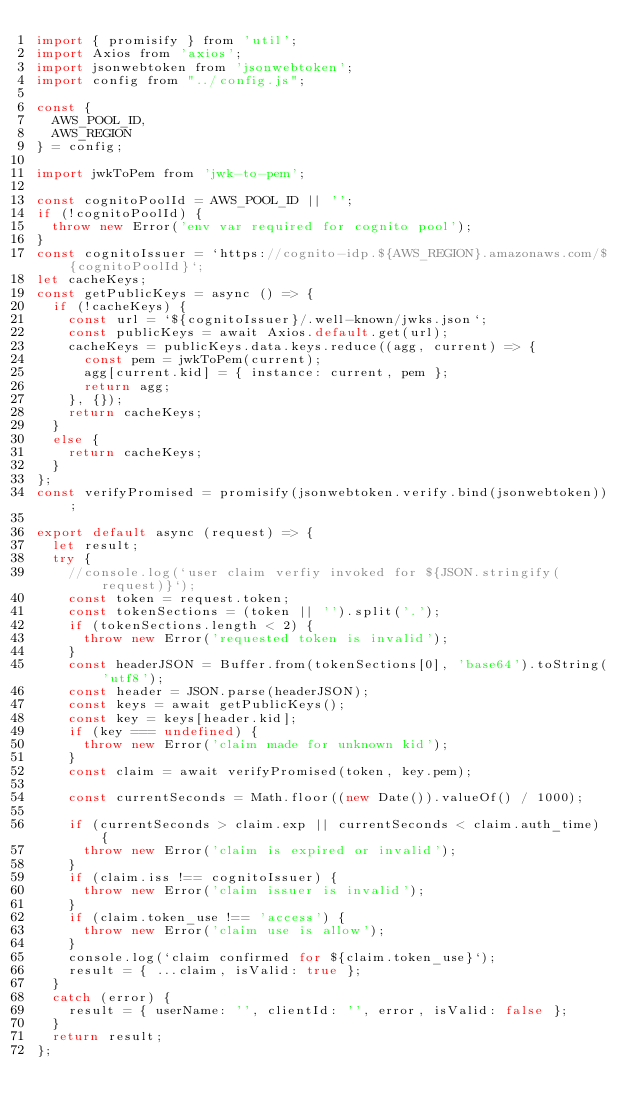Convert code to text. <code><loc_0><loc_0><loc_500><loc_500><_JavaScript_>import { promisify } from 'util';
import Axios from 'axios';
import jsonwebtoken from 'jsonwebtoken';
import config from "../config.js";

const {
  AWS_POOL_ID,
  AWS_REGION
} = config;

import jwkToPem from 'jwk-to-pem';

const cognitoPoolId = AWS_POOL_ID || '';
if (!cognitoPoolId) {
  throw new Error('env var required for cognito pool');
}
const cognitoIssuer = `https://cognito-idp.${AWS_REGION}.amazonaws.com/${cognitoPoolId}`;
let cacheKeys;
const getPublicKeys = async () => {
  if (!cacheKeys) {
    const url = `${cognitoIssuer}/.well-known/jwks.json`;
    const publicKeys = await Axios.default.get(url);
    cacheKeys = publicKeys.data.keys.reduce((agg, current) => {
      const pem = jwkToPem(current);
      agg[current.kid] = { instance: current, pem };
      return agg;
    }, {});
    return cacheKeys;
  }
  else {
    return cacheKeys;
  }
};
const verifyPromised = promisify(jsonwebtoken.verify.bind(jsonwebtoken));

export default async (request) => {
  let result;
  try {
    //console.log(`user claim verfiy invoked for ${JSON.stringify(request)}`);
    const token = request.token;
    const tokenSections = (token || '').split('.');
    if (tokenSections.length < 2) {
      throw new Error('requested token is invalid');
    }
    const headerJSON = Buffer.from(tokenSections[0], 'base64').toString('utf8');
    const header = JSON.parse(headerJSON);
    const keys = await getPublicKeys();
    const key = keys[header.kid];
    if (key === undefined) {
      throw new Error('claim made for unknown kid');
    }
    const claim = await verifyPromised(token, key.pem);

    const currentSeconds = Math.floor((new Date()).valueOf() / 1000);
    
    if (currentSeconds > claim.exp || currentSeconds < claim.auth_time) {
      throw new Error('claim is expired or invalid');
    }
    if (claim.iss !== cognitoIssuer) {
      throw new Error('claim issuer is invalid');
    }
    if (claim.token_use !== 'access') {
      throw new Error('claim use is allow');
    }
    console.log(`claim confirmed for ${claim.token_use}`);
    result = { ...claim, isValid: true };
  }
  catch (error) {
    result = { userName: '', clientId: '', error, isValid: false };
  }
  return result;
};

</code> 